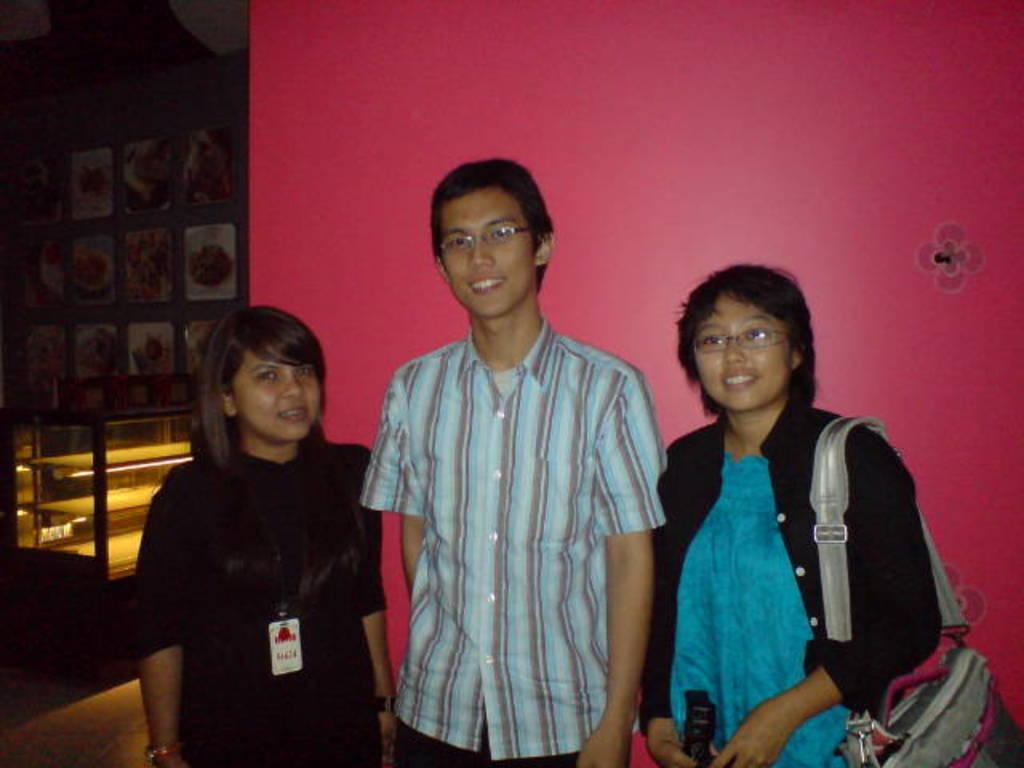Can you describe this image briefly? In this image I can see a man and two women are standing in the front. I can see one of them is carrying a bag and two of them are wearing specs. In the background I can see pink colour wall and on the left side of this image I can see number of frames. 